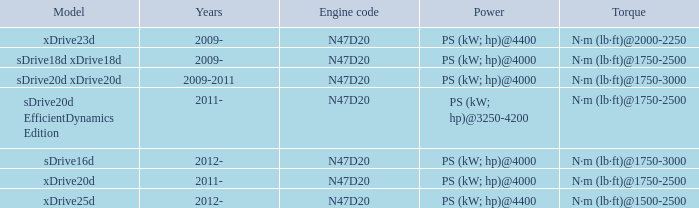Help me parse the entirety of this table. {'header': ['Model', 'Years', 'Engine code', 'Power', 'Torque'], 'rows': [['xDrive23d', '2009-', 'N47D20', 'PS (kW; hp)@4400', 'N·m (lb·ft)@2000-2250'], ['sDrive18d xDrive18d', '2009-', 'N47D20', 'PS (kW; hp)@4000', 'N·m (lb·ft)@1750-2500'], ['sDrive20d xDrive20d', '2009-2011', 'N47D20', 'PS (kW; hp)@4000', 'N·m (lb·ft)@1750-3000'], ['sDrive20d EfficientDynamics Edition', '2011-', 'N47D20', 'PS (kW; hp)@3250-4200', 'N·m (lb·ft)@1750-2500'], ['sDrive16d', '2012-', 'N47D20', 'PS (kW; hp)@4000', 'N·m (lb·ft)@1750-3000'], ['xDrive20d', '2011-', 'N47D20', 'PS (kW; hp)@4000', 'N·m (lb·ft)@1750-2500'], ['xDrive25d', '2012-', 'N47D20', 'PS (kW; hp)@4400', 'N·m (lb·ft)@1500-2500']]} What model is the n·m (lb·ft)@1500-2500 torque? Xdrive25d. 